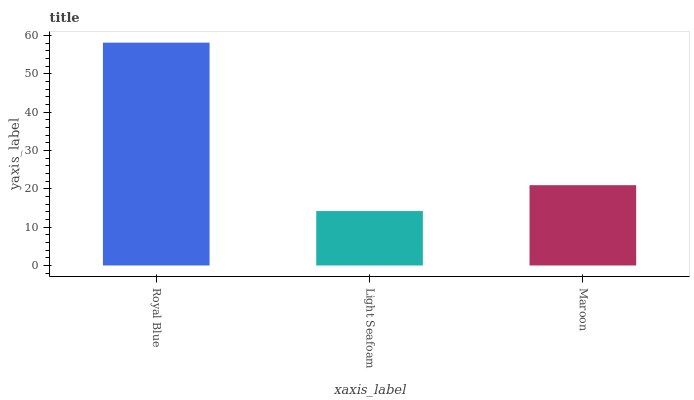Is Light Seafoam the minimum?
Answer yes or no. Yes. Is Royal Blue the maximum?
Answer yes or no. Yes. Is Maroon the minimum?
Answer yes or no. No. Is Maroon the maximum?
Answer yes or no. No. Is Maroon greater than Light Seafoam?
Answer yes or no. Yes. Is Light Seafoam less than Maroon?
Answer yes or no. Yes. Is Light Seafoam greater than Maroon?
Answer yes or no. No. Is Maroon less than Light Seafoam?
Answer yes or no. No. Is Maroon the high median?
Answer yes or no. Yes. Is Maroon the low median?
Answer yes or no. Yes. Is Royal Blue the high median?
Answer yes or no. No. Is Royal Blue the low median?
Answer yes or no. No. 